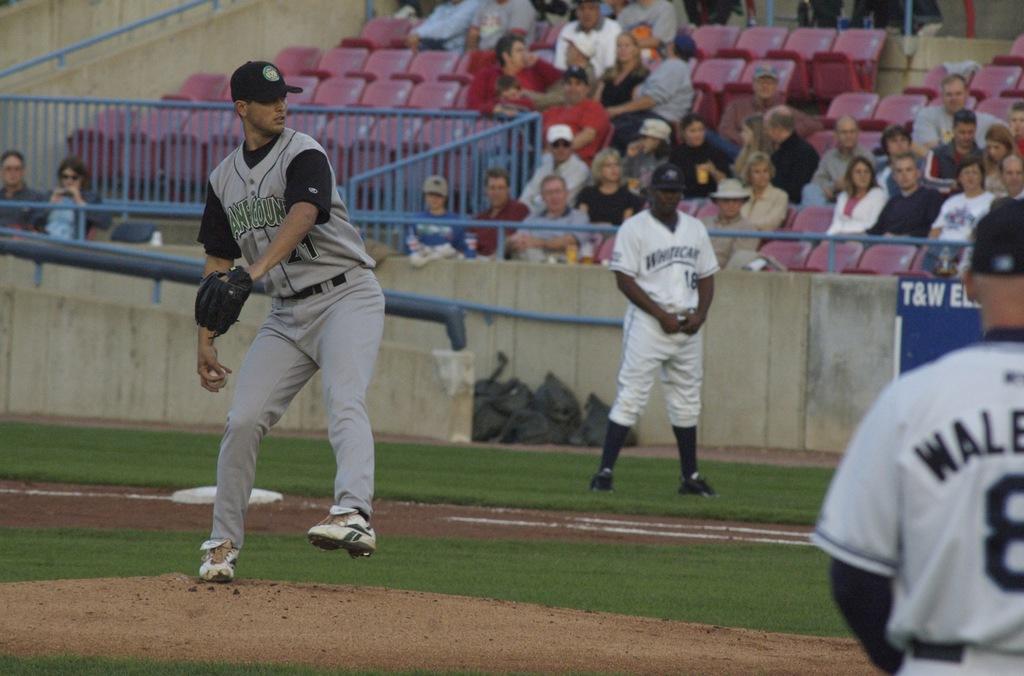What number is the third base coach?
Your answer should be very brief. Unanswerable. 